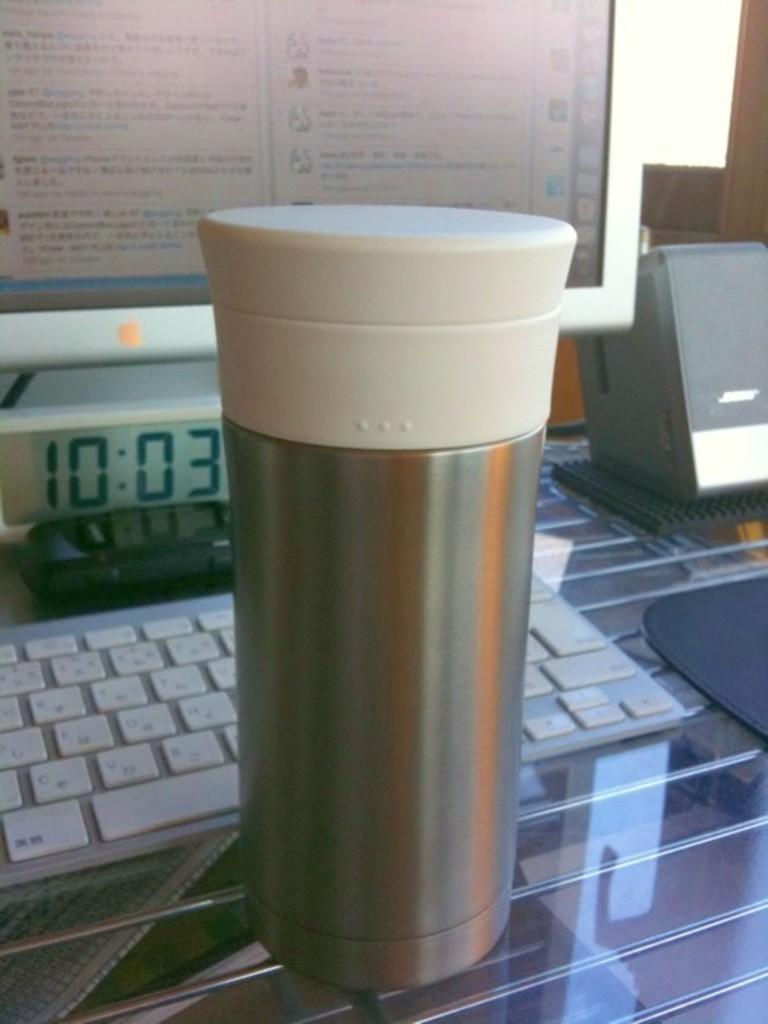<image>
Describe the image concisely. A coffee mug in front of a computer which has the clock time of 10:03. 